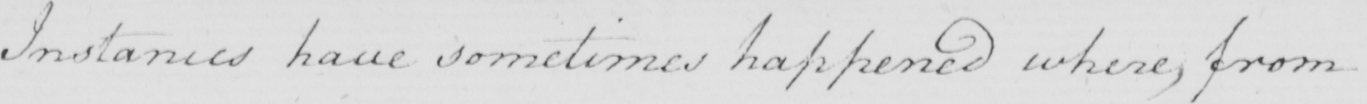What is written in this line of handwriting? Instances have sometimes happened where , from 